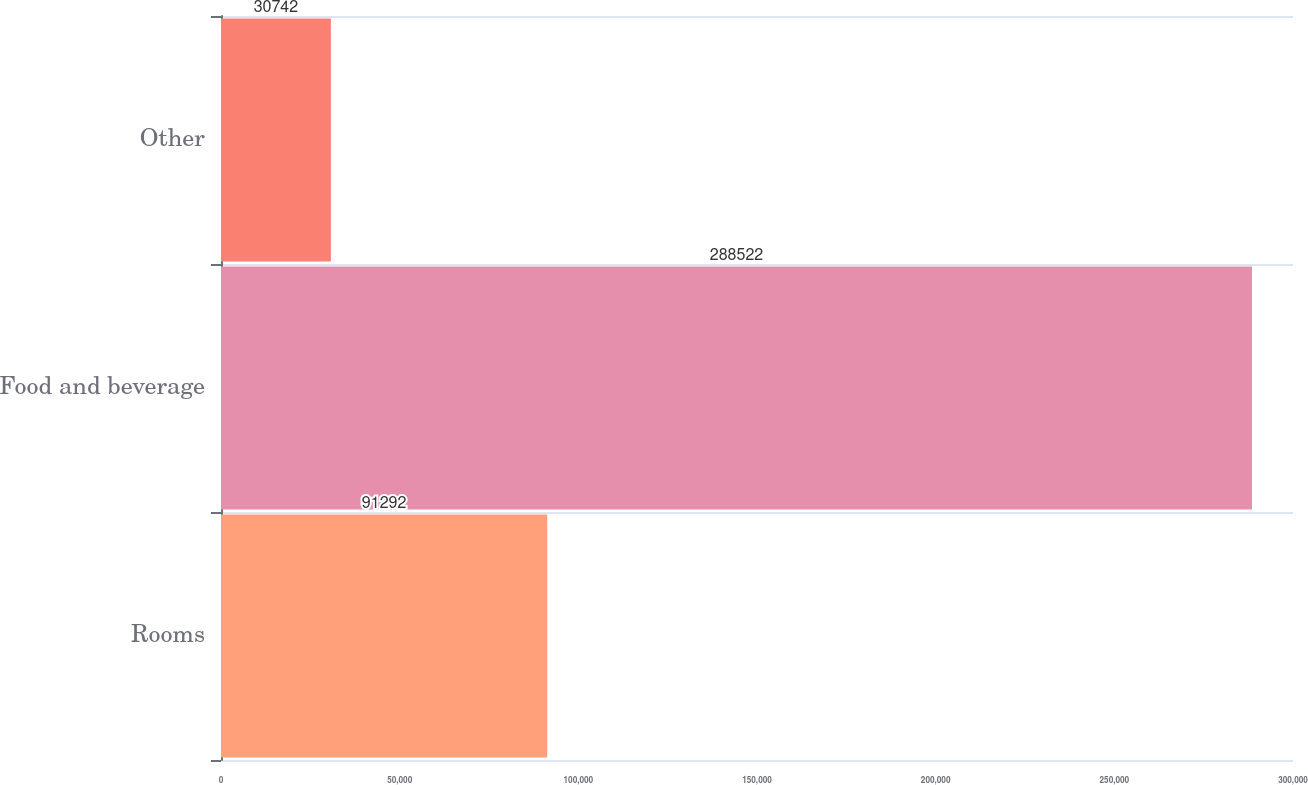Convert chart. <chart><loc_0><loc_0><loc_500><loc_500><bar_chart><fcel>Rooms<fcel>Food and beverage<fcel>Other<nl><fcel>91292<fcel>288522<fcel>30742<nl></chart> 